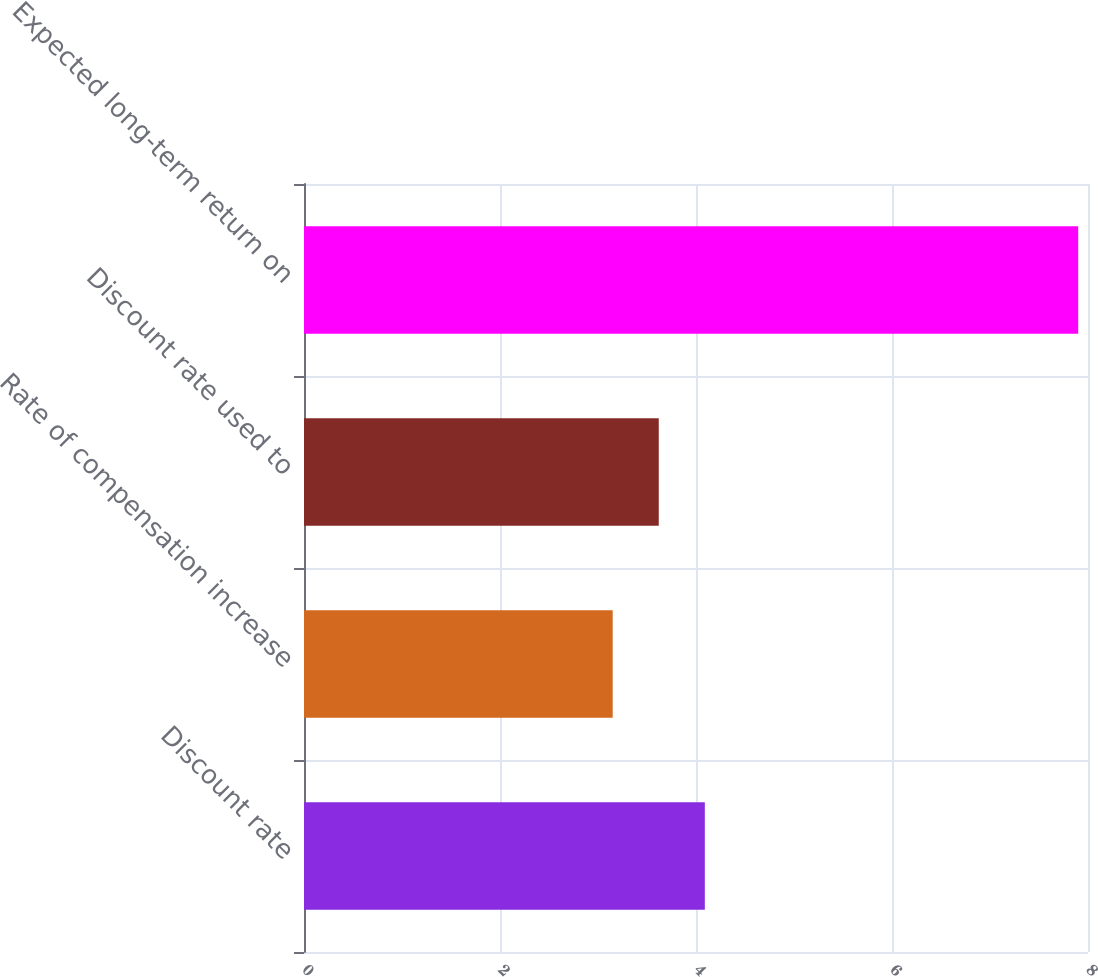Convert chart. <chart><loc_0><loc_0><loc_500><loc_500><bar_chart><fcel>Discount rate<fcel>Rate of compensation increase<fcel>Discount rate used to<fcel>Expected long-term return on<nl><fcel>4.09<fcel>3.15<fcel>3.62<fcel>7.9<nl></chart> 